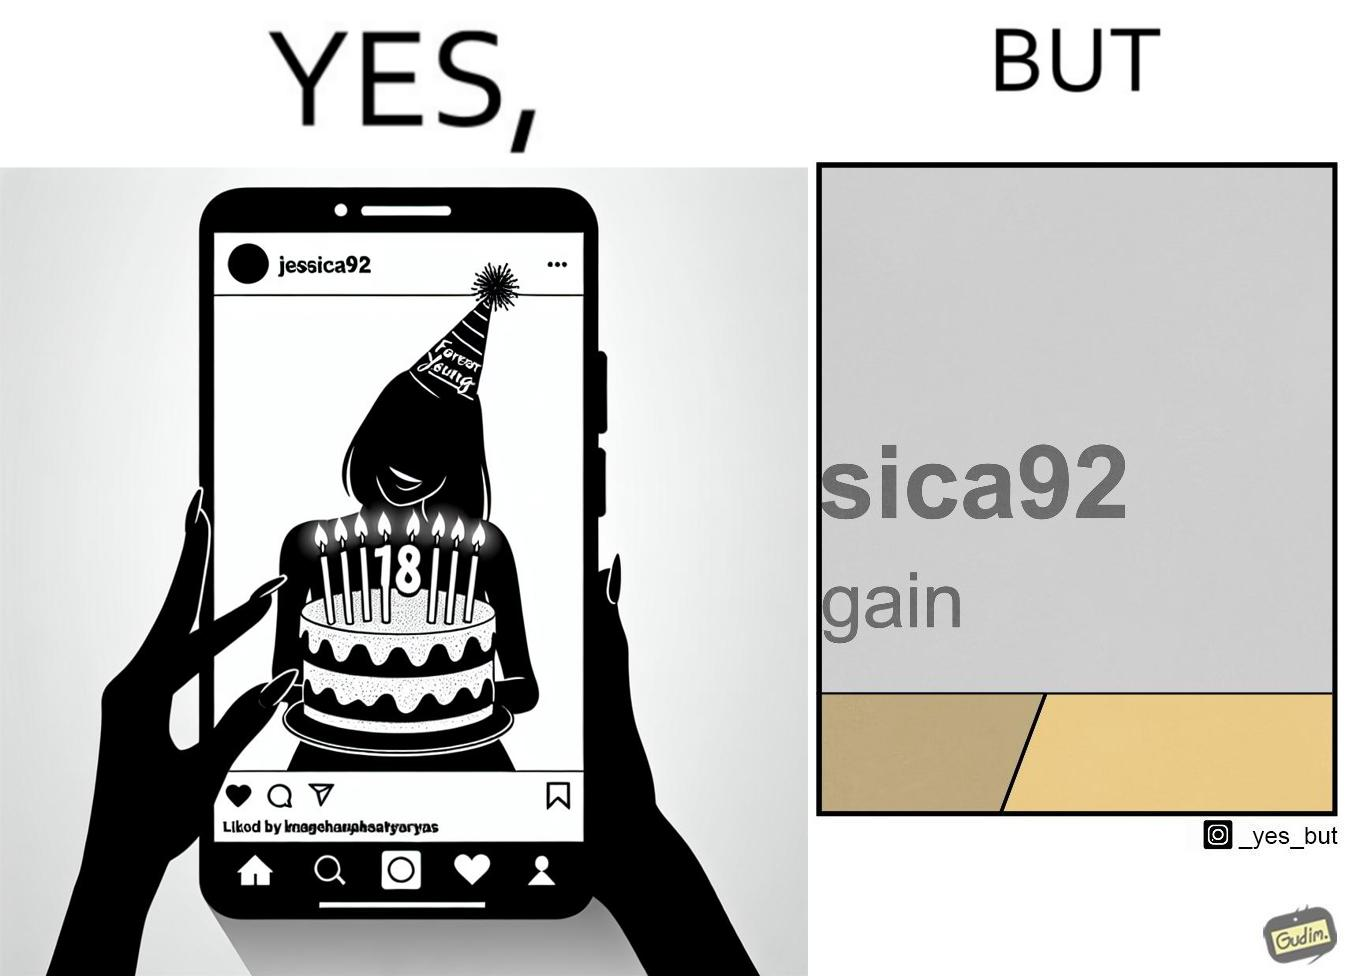Does this image contain satire or humor? Yes, this image is satirical. 